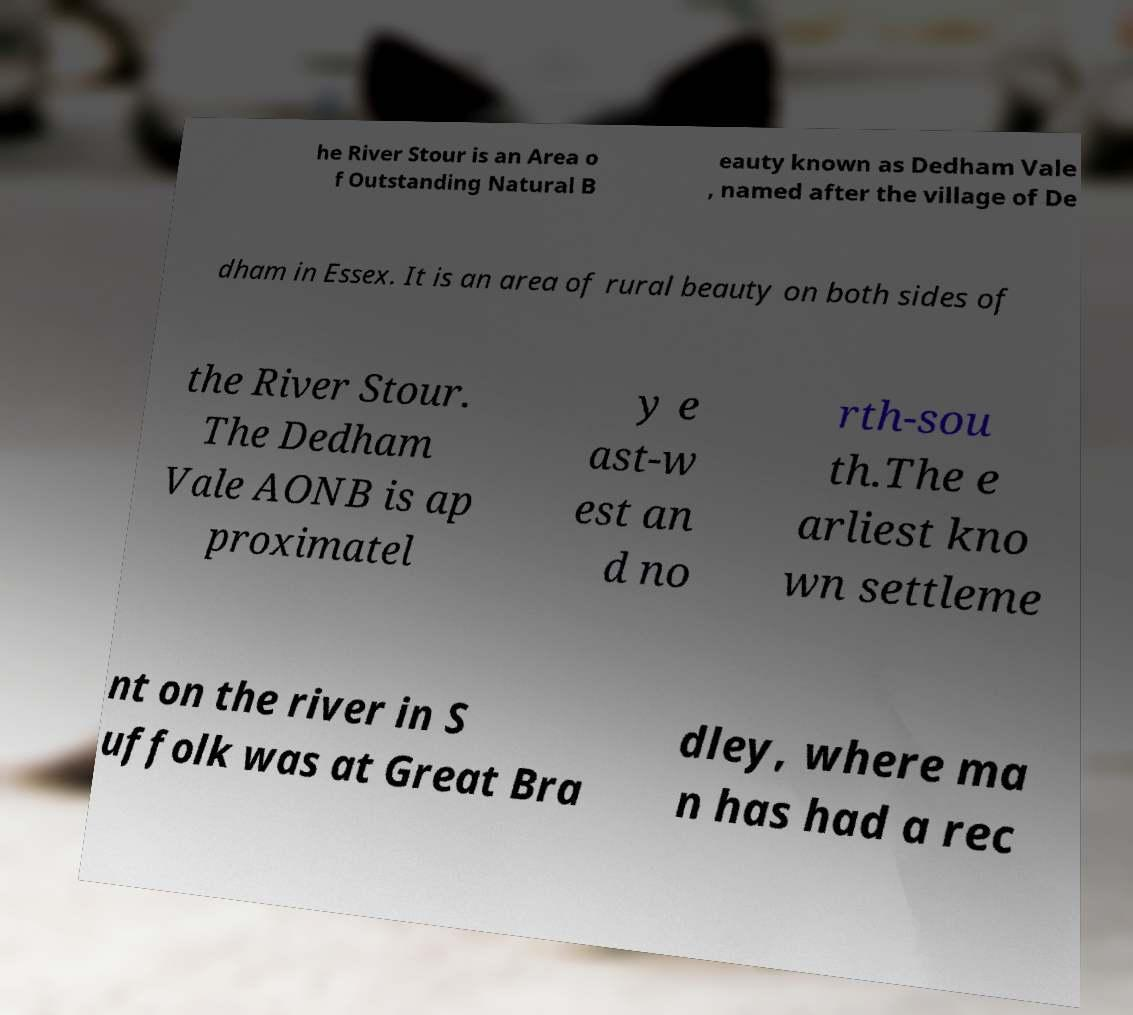Can you read and provide the text displayed in the image?This photo seems to have some interesting text. Can you extract and type it out for me? he River Stour is an Area o f Outstanding Natural B eauty known as Dedham Vale , named after the village of De dham in Essex. It is an area of rural beauty on both sides of the River Stour. The Dedham Vale AONB is ap proximatel y e ast-w est an d no rth-sou th.The e arliest kno wn settleme nt on the river in S uffolk was at Great Bra dley, where ma n has had a rec 